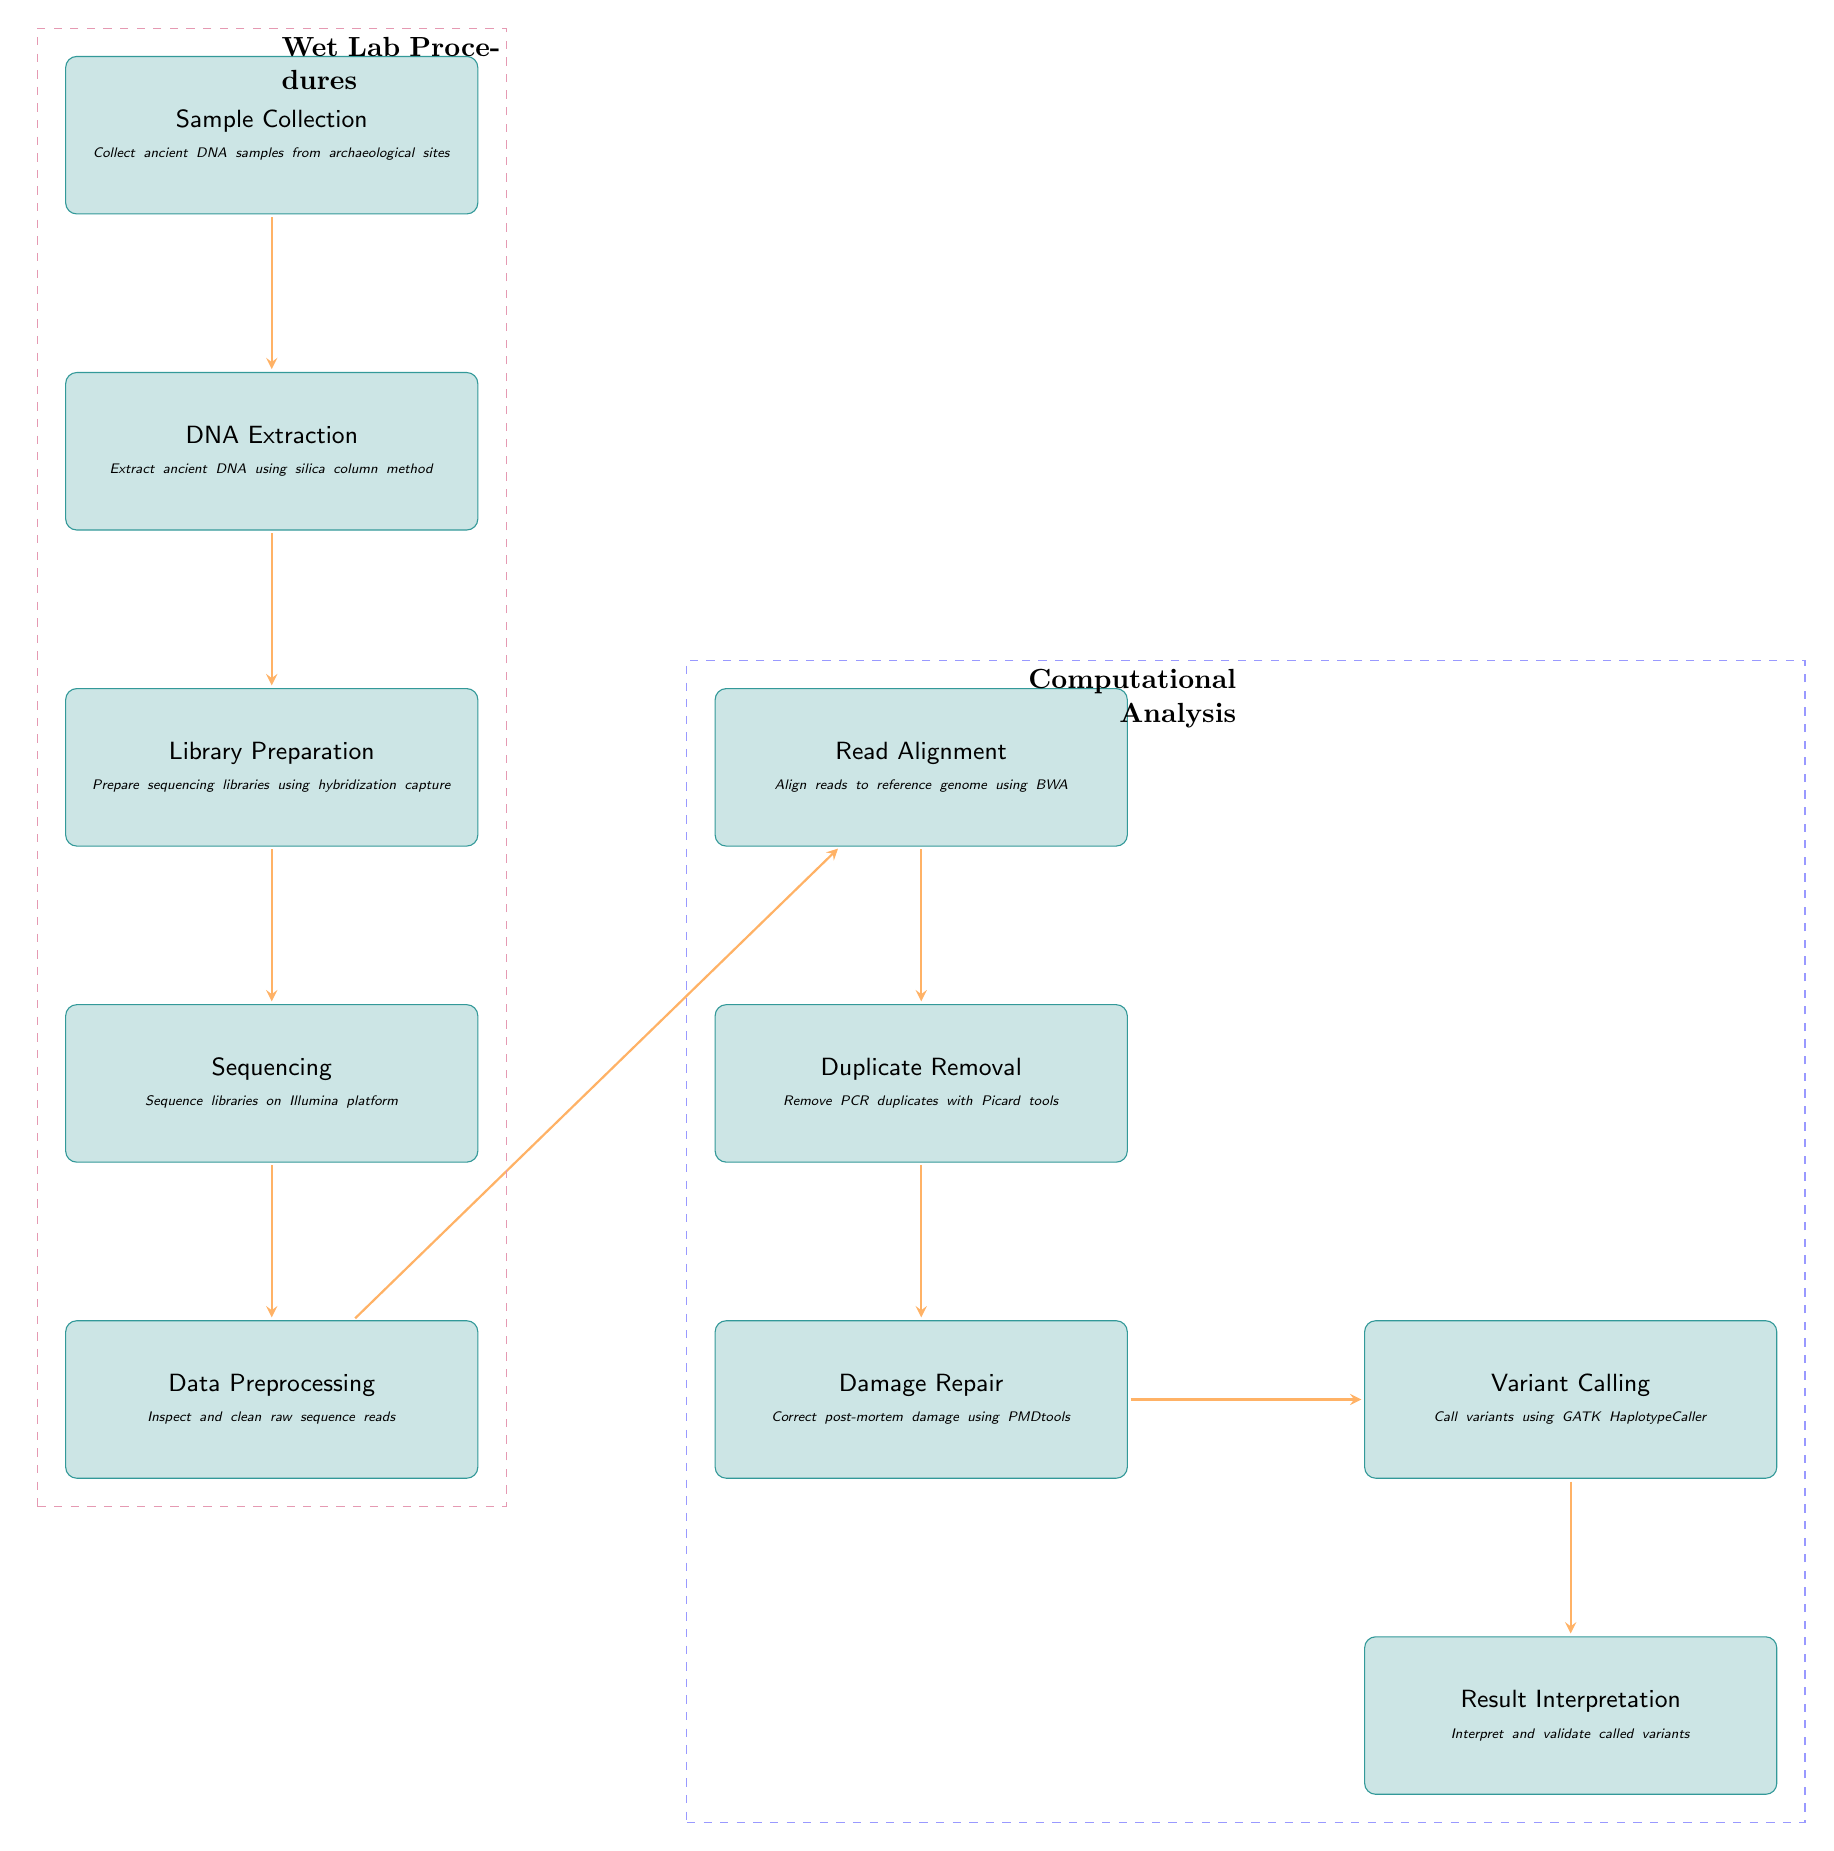What is the first step in the workflow pipeline? The first step in the workflow pipeline is indicated at the top of the diagram. It shows "Sample Collection" as the initial process in the sequence.
Answer: Sample Collection How many main stages are there in the diagram? The diagram contains two main stages, which are separated into "Wet Lab Procedures" and "Computational Analysis," each containing various processes.
Answer: 2 What tool is used for read alignment? The diagram explicitly states that "BWA" is the tool used for read alignment in the "Read Alignment" process.
Answer: BWA What follows after the "Sequencing" step? According to the flow in the diagram, after the "Sequencing" step, the next step is "Data Preprocessing."
Answer: Data Preprocessing Which process comes directly after "Damage Repair"? The diagram shows that "Damage Repair" is followed directly by "Variant Calling," representing the next step in the workflow.
Answer: Variant Calling What does the dashed rectangle labeled "Wet Lab Procedures" encompass? The dashed rectangle labeled "Wet Lab Procedures" encompasses the steps "Sample Collection," "DNA Extraction," "Library Preparation," and "Sequencing," which are all in the wet lab phase of the workflow.
Answer: Sample Collection, DNA Extraction, Library Preparation, Sequencing What is the purpose of the "Duplicate Removal" step? The diagram describes the "Duplicate Removal" step as the process where PCR duplicates are removed using specific tools.
Answer: Remove PCR duplicates with Picard tools How is result interpretation performed? In the final step labeled "Result Interpretation," the diagram indicates that the process involves interpreting and validating the called variants, showcasing its role in the analysis pipeline.
Answer: Interpret and validate called variants 